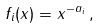<formula> <loc_0><loc_0><loc_500><loc_500>f _ { i } ( x ) = x ^ { - a _ { i } } \, ,</formula> 